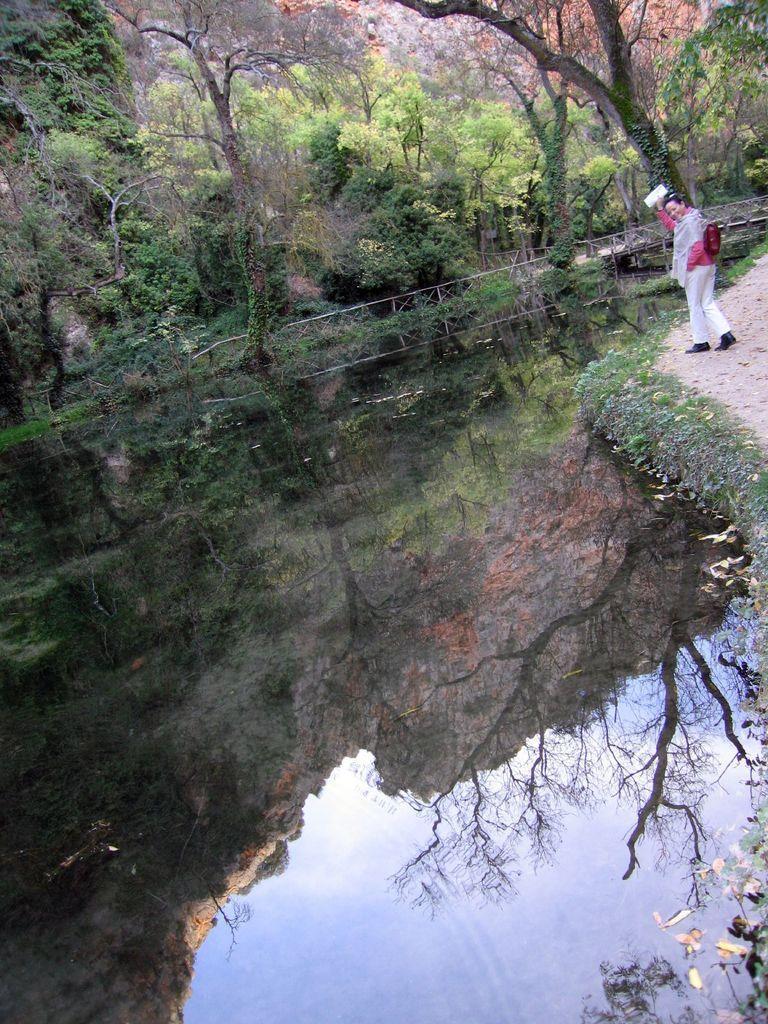Please provide a concise description of this image. There is a lake, beside the lake a woman is walking on the path there are plenty of trees around the lake and there is a bridge constructed across the lake. 